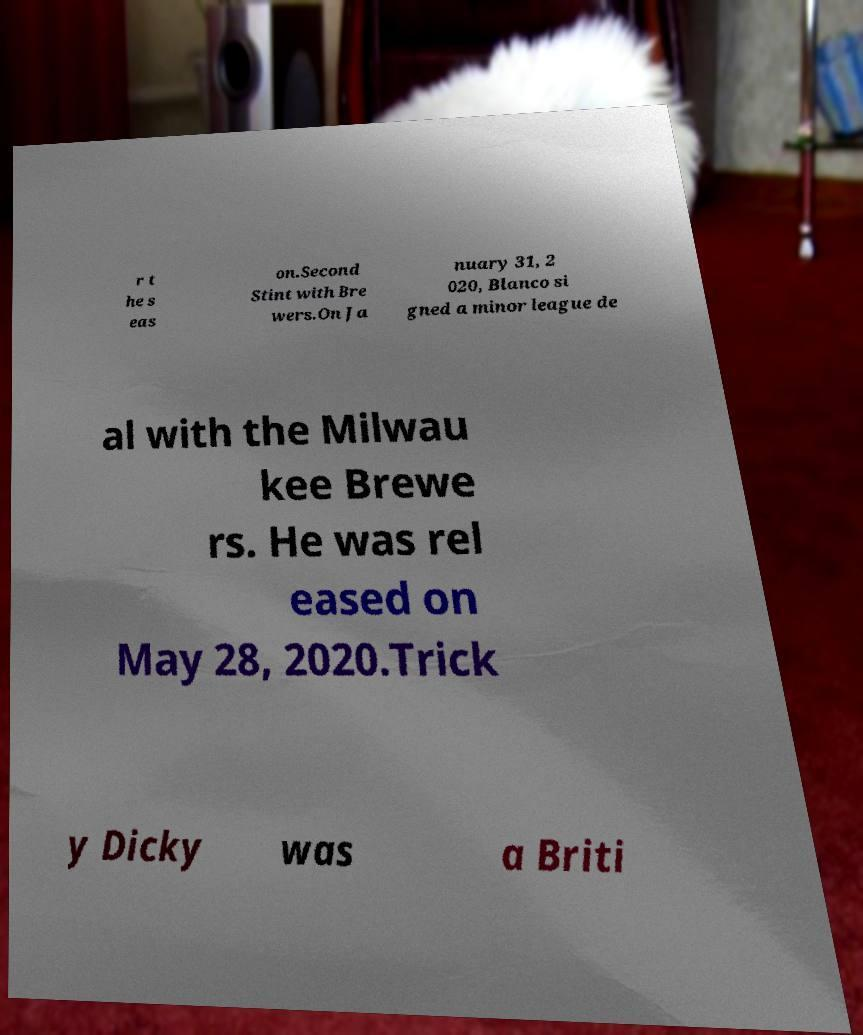I need the written content from this picture converted into text. Can you do that? r t he s eas on.Second Stint with Bre wers.On Ja nuary 31, 2 020, Blanco si gned a minor league de al with the Milwau kee Brewe rs. He was rel eased on May 28, 2020.Trick y Dicky was a Briti 